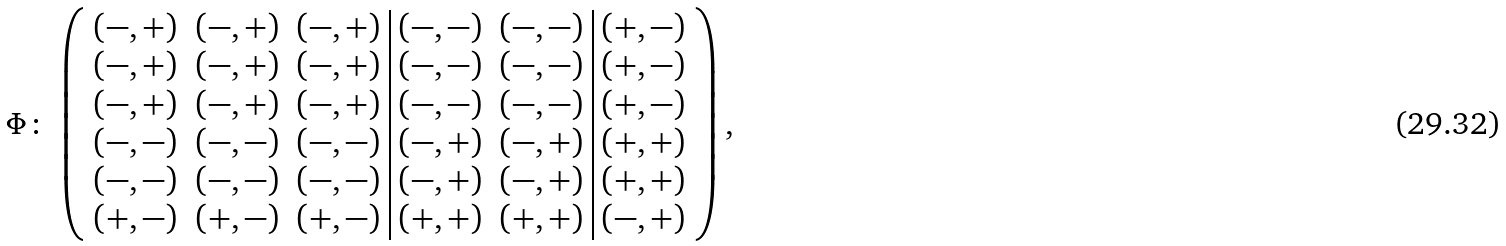<formula> <loc_0><loc_0><loc_500><loc_500>\Phi \colon \, \left ( \begin{array} { c c c | c c | c } ( - , + ) & ( - , + ) & ( - , + ) & ( - , - ) & ( - , - ) & ( + , - ) \\ ( - , + ) & ( - , + ) & ( - , + ) & ( - , - ) & ( - , - ) & ( + , - ) \\ ( - , + ) & ( - , + ) & ( - , + ) & ( - , - ) & ( - , - ) & ( + , - ) \\ ( - , - ) & ( - , - ) & ( - , - ) & ( - , + ) & ( - , + ) & ( + , + ) \\ ( - , - ) & ( - , - ) & ( - , - ) & ( - , + ) & ( - , + ) & ( + , + ) \\ ( + , - ) & ( + , - ) & ( + , - ) & ( + , + ) & ( + , + ) & ( - , + ) \end{array} \right ) ,</formula> 